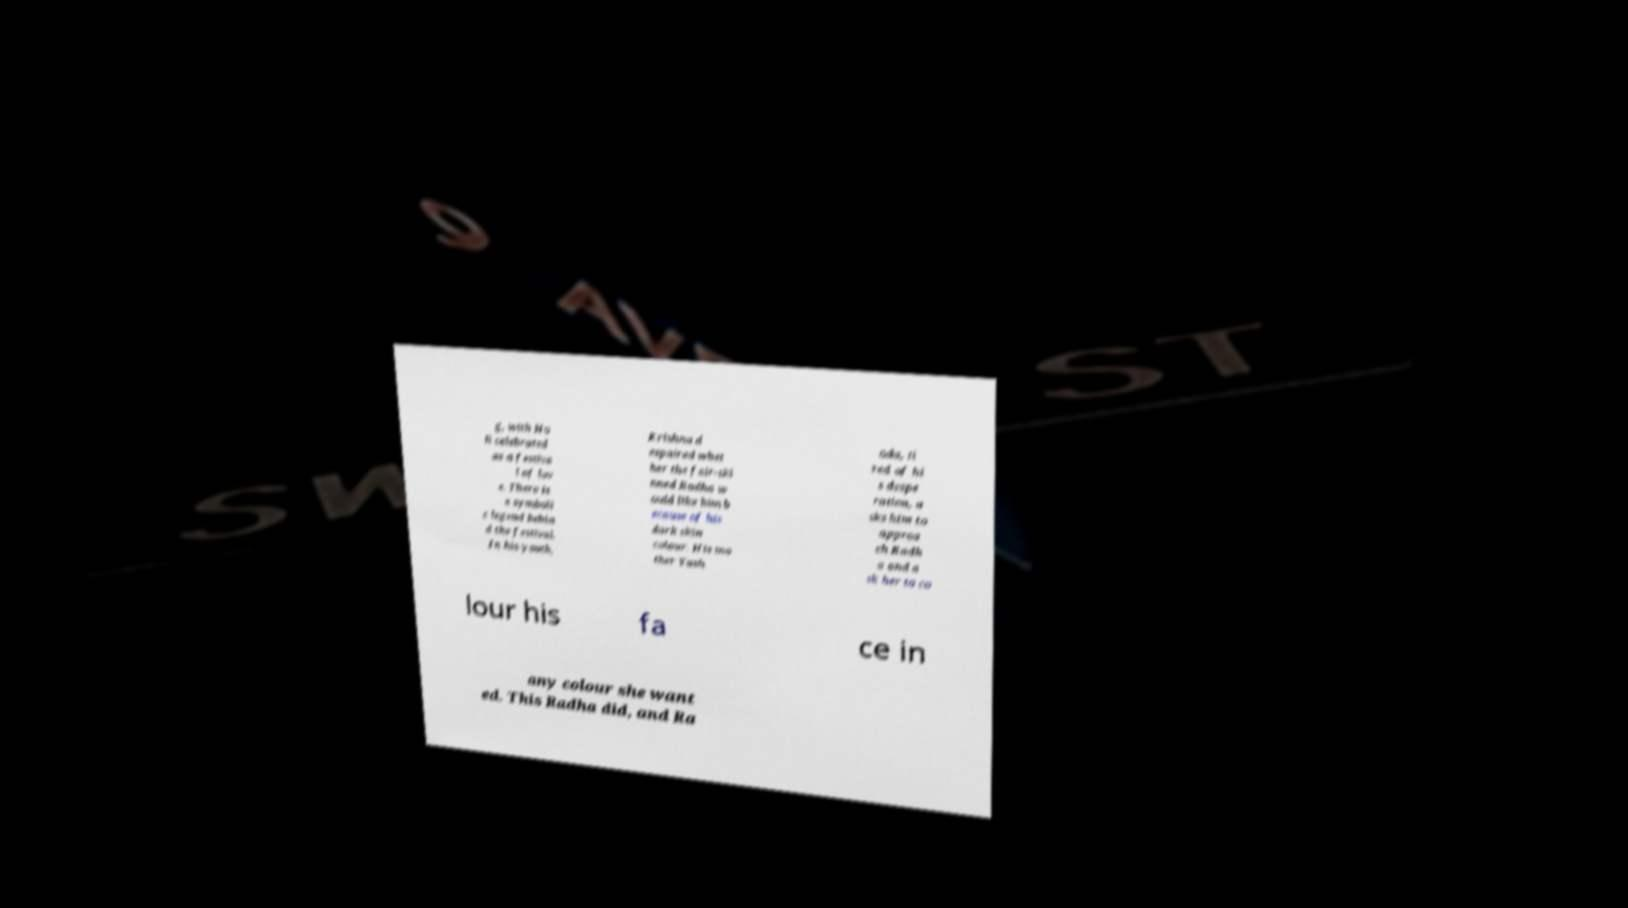Could you assist in decoding the text presented in this image and type it out clearly? g, with Ho li celebrated as a festiva l of lov e. There is a symboli c legend behin d the festival. In his youth, Krishna d espaired whet her the fair-ski nned Radha w ould like him b ecause of his dark skin colour. His mo ther Yash oda, ti red of hi s despe ration, a sks him to approa ch Radh a and a sk her to co lour his fa ce in any colour she want ed. This Radha did, and Ra 